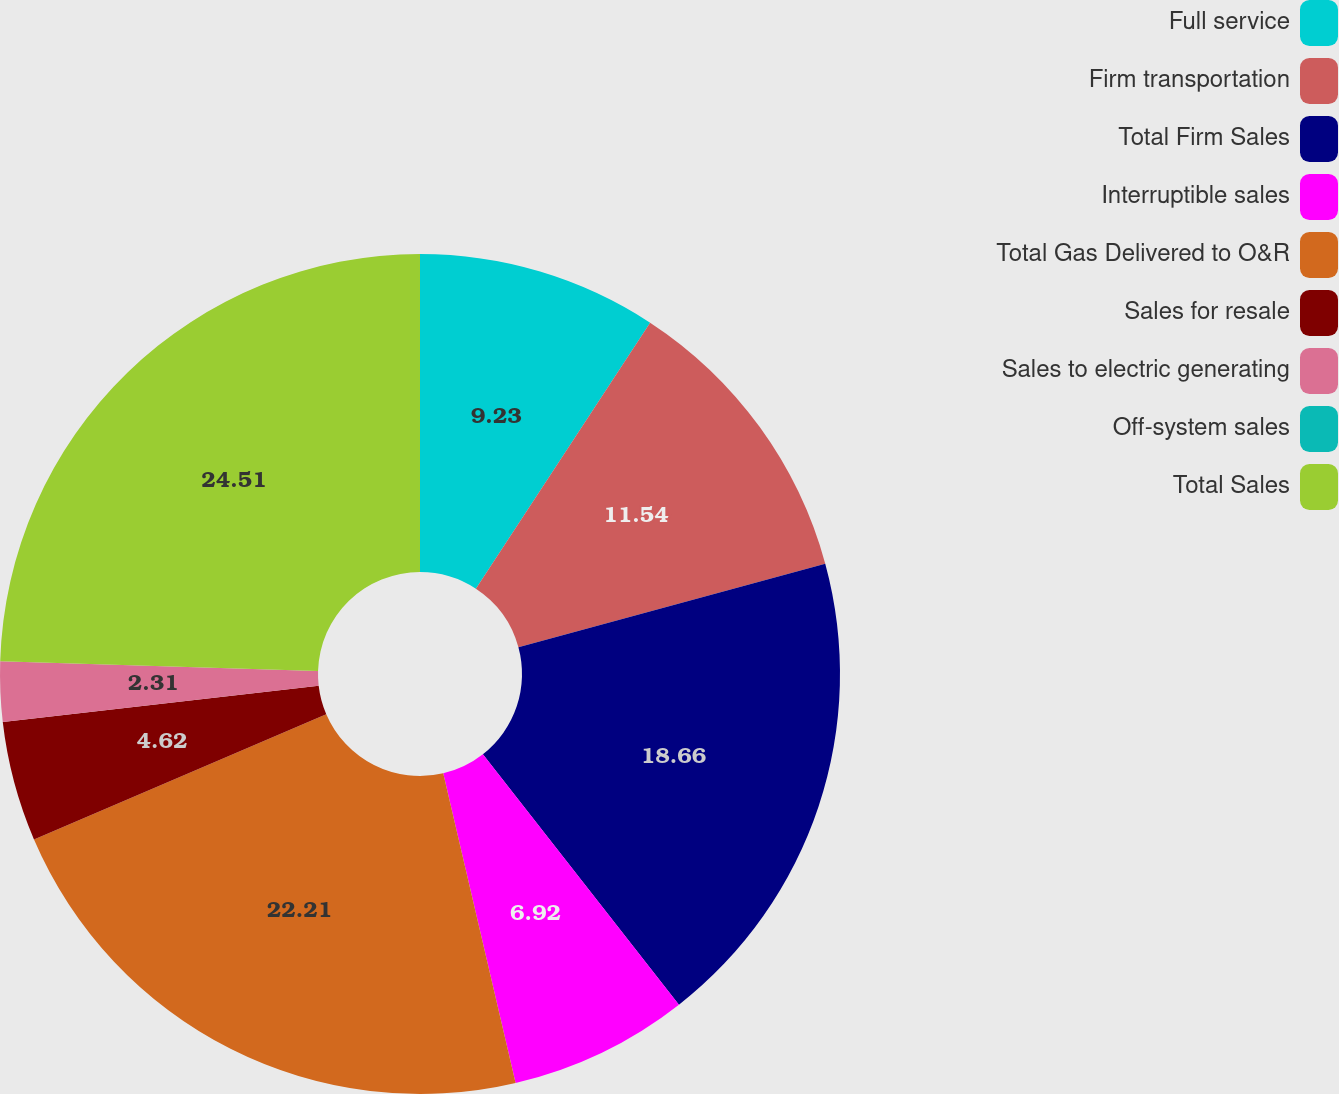Convert chart. <chart><loc_0><loc_0><loc_500><loc_500><pie_chart><fcel>Full service<fcel>Firm transportation<fcel>Total Firm Sales<fcel>Interruptible sales<fcel>Total Gas Delivered to O&R<fcel>Sales for resale<fcel>Sales to electric generating<fcel>Off-system sales<fcel>Total Sales<nl><fcel>9.23%<fcel>11.54%<fcel>18.66%<fcel>6.92%<fcel>22.21%<fcel>4.62%<fcel>2.31%<fcel>0.0%<fcel>24.52%<nl></chart> 